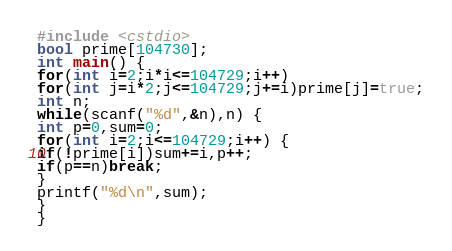Convert code to text. <code><loc_0><loc_0><loc_500><loc_500><_C++_>#include <cstdio>
bool prime[104730];
int main() {
for(int i=2;i*i<=104729;i++)
for(int j=i*2;j<=104729;j+=i)prime[j]=true;
int n;
while(scanf("%d",&n),n) {
int p=0,sum=0;
for(int i=2;i<=104729;i++) {
if(!prime[i])sum+=i,p++;
if(p==n)break;
}
printf("%d\n",sum);
}
}</code> 